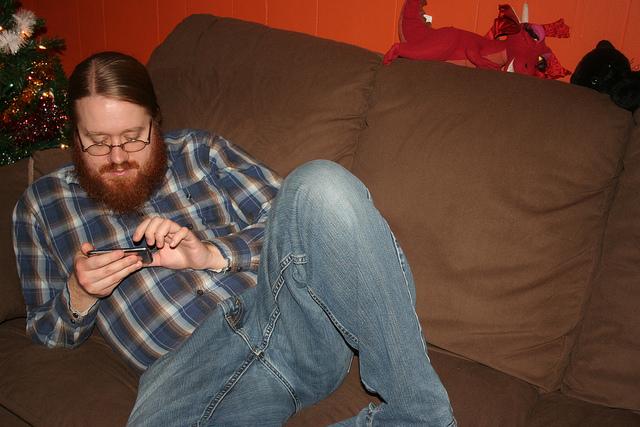What holiday was this picture taken during?
Give a very brief answer. Christmas. Is that a cell phone in his hand?
Quick response, please. Yes. Is the man wearing glasses?
Be succinct. Yes. 